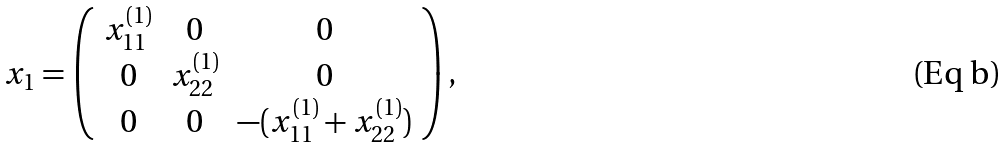Convert formula to latex. <formula><loc_0><loc_0><loc_500><loc_500>x _ { 1 } = \left ( \begin{array} { c c c } x _ { 1 1 } ^ { ( 1 ) } & 0 & 0 \\ 0 & x _ { 2 2 } ^ { ( 1 ) } & 0 \\ 0 & 0 & - ( x _ { 1 1 } ^ { ( 1 ) } + x _ { 2 2 } ^ { ( 1 ) } ) \\ \end{array} \right ) ,</formula> 